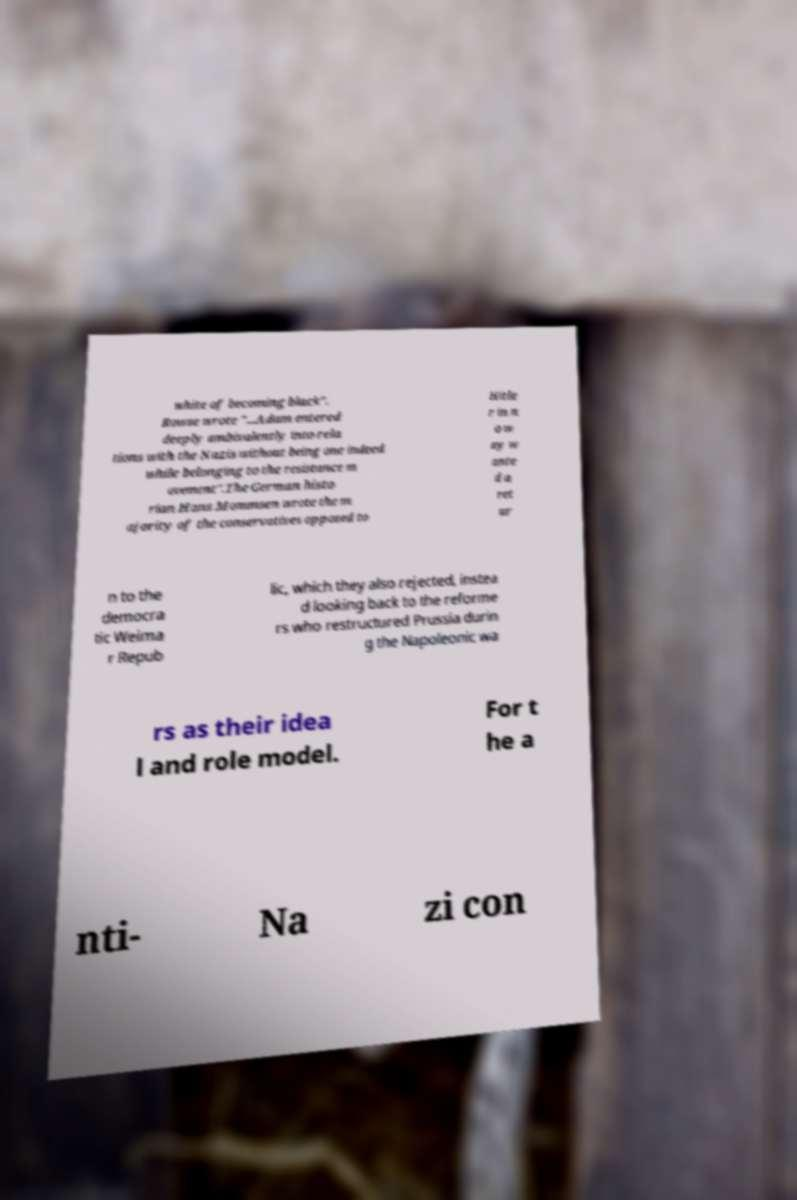Please read and relay the text visible in this image. What does it say? white of becoming black". Rowse wrote "...Adam entered deeply ambivalently into rela tions with the Nazis without being one indeed while belonging to the resistance m ovement".The German histo rian Hans Mommsen wrote the m ajority of the conservatives opposed to Hitle r in n o w ay w ante d a ret ur n to the democra tic Weima r Repub lic, which they also rejected, instea d looking back to the reforme rs who restructured Prussia durin g the Napoleonic wa rs as their idea l and role model. For t he a nti- Na zi con 